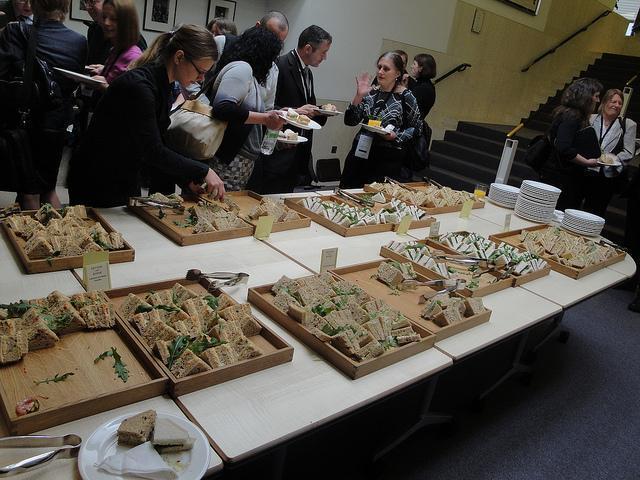How many dining tables can be seen?
Give a very brief answer. 5. How many people can be seen?
Give a very brief answer. 8. 